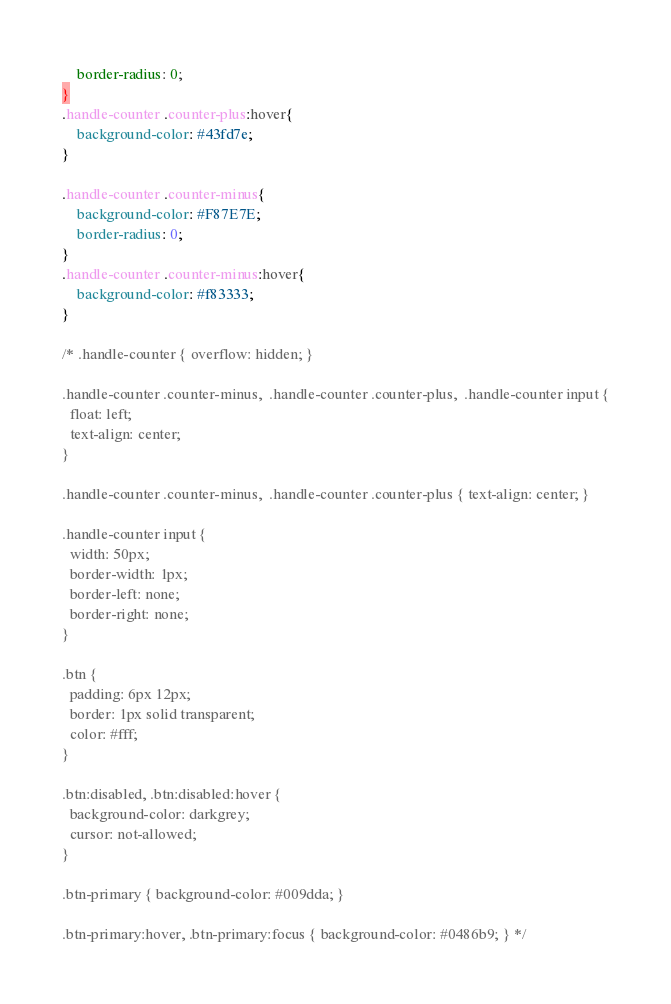<code> <loc_0><loc_0><loc_500><loc_500><_CSS_>    border-radius: 0;
}
.handle-counter .counter-plus:hover{
    background-color: #43fd7e;
}

.handle-counter .counter-minus{
    background-color: #F87E7E;
    border-radius: 0;
}
.handle-counter .counter-minus:hover{
    background-color: #f83333;
}

/* .handle-counter { overflow: hidden; }

.handle-counter .counter-minus,  .handle-counter .counter-plus,  .handle-counter input {
  float: left;
  text-align: center;
}

.handle-counter .counter-minus,  .handle-counter .counter-plus { text-align: center; }

.handle-counter input {
  width: 50px;
  border-width: 1px;
  border-left: none;
  border-right: none;
}

.btn {
  padding: 6px 12px;
  border: 1px solid transparent;
  color: #fff;
}

.btn:disabled, .btn:disabled:hover {
  background-color: darkgrey;
  cursor: not-allowed;
}

.btn-primary { background-color: #009dda; }

.btn-primary:hover, .btn-primary:focus { background-color: #0486b9; } */
</code> 